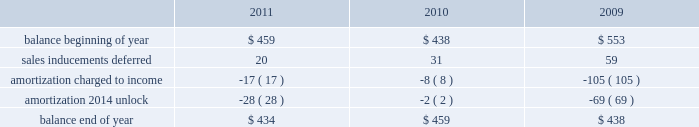The hartford financial services group , inc .
Notes to consolidated financial statements ( continued ) 10 .
Sales inducements accounting policy the company currently offers enhanced crediting rates or bonus payments to contract holders on certain of its individual and group annuity products .
The expense associated with offering a bonus is deferred and amortized over the life of the related contract in a pattern consistent with the amortization of deferred policy acquisition costs .
Amortization expense associated with expenses previously deferred is recorded over the remaining life of the contract .
Consistent with the unlock , the company unlocked the amortization of the sales inducement asset .
See note 7 for more information concerning the unlock .
Changes in deferred sales inducement activity were as follows for the years ended december 31: .
11 .
Reserves for future policy benefits and unpaid losses and loss adjustment expenses life insurance products accounting policy liabilities for future policy benefits are calculated by the net level premium method using interest , withdrawal and mortality assumptions appropriate at the time the policies were issued .
The methods used in determining the liability for unpaid losses and future policy benefits are standard actuarial methods recognized by the american academy of actuaries .
For the tabular reserves , discount rates are based on the company 2019s earned investment yield and the morbidity/mortality tables used are standard industry tables modified to reflect the company 2019s actual experience when appropriate .
In particular , for the company 2019s group disability known claim reserves , the morbidity table for the early durations of claim is based exclusively on the company 2019s experience , incorporating factors such as gender , elimination period and diagnosis .
These reserves are computed such that they are expected to meet the company 2019s future policy obligations .
Future policy benefits are computed at amounts that , with additions from estimated premiums to be received and with interest on such reserves compounded annually at certain assumed rates , are expected to be sufficient to meet the company 2019s policy obligations at their maturities or in the event of an insured 2019s death .
Changes in or deviations from the assumptions used for mortality , morbidity , expected future premiums and interest can significantly affect the company 2019s reserve levels and related future operations and , as such , provisions for adverse deviation are built into the long-tailed liability assumptions .
Liabilities for the company 2019s group life and disability contracts , as well as its individual term life insurance policies , include amounts for unpaid losses and future policy benefits .
Liabilities for unpaid losses include estimates of amounts to fully settle known reported claims , as well as claims related to insured events that the company estimates have been incurred but have not yet been reported .
These reserve estimates are based on known facts and interpretations of circumstances , and consideration of various internal factors including the hartford 2019s experience with similar cases , historical trends involving claim payment patterns , loss payments , pending levels of unpaid claims , loss control programs and product mix .
In addition , the reserve estimates are influenced by consideration of various external factors including court decisions , economic conditions and public attitudes .
The effects of inflation are implicitly considered in the reserving process. .
What is the net change in the balance of deferred sales in 2011? 
Computations: (434 - 459)
Answer: -25.0. 